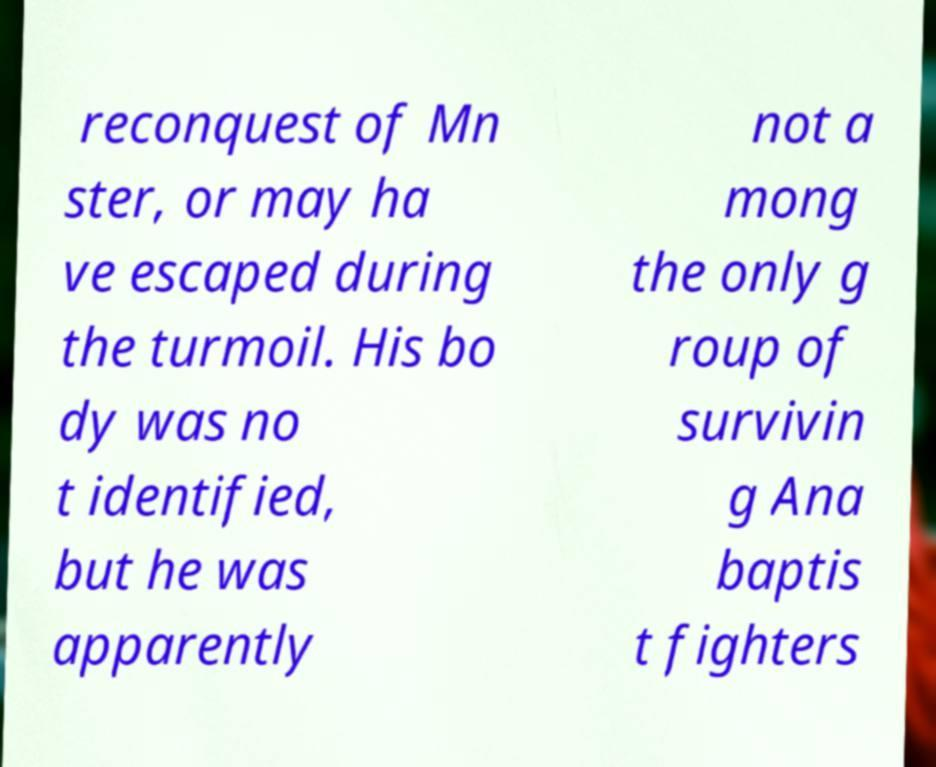Can you accurately transcribe the text from the provided image for me? reconquest of Mn ster, or may ha ve escaped during the turmoil. His bo dy was no t identified, but he was apparently not a mong the only g roup of survivin g Ana baptis t fighters 